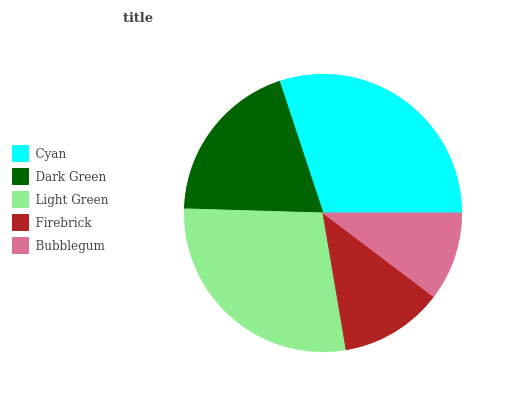Is Bubblegum the minimum?
Answer yes or no. Yes. Is Cyan the maximum?
Answer yes or no. Yes. Is Dark Green the minimum?
Answer yes or no. No. Is Dark Green the maximum?
Answer yes or no. No. Is Cyan greater than Dark Green?
Answer yes or no. Yes. Is Dark Green less than Cyan?
Answer yes or no. Yes. Is Dark Green greater than Cyan?
Answer yes or no. No. Is Cyan less than Dark Green?
Answer yes or no. No. Is Dark Green the high median?
Answer yes or no. Yes. Is Dark Green the low median?
Answer yes or no. Yes. Is Light Green the high median?
Answer yes or no. No. Is Firebrick the low median?
Answer yes or no. No. 